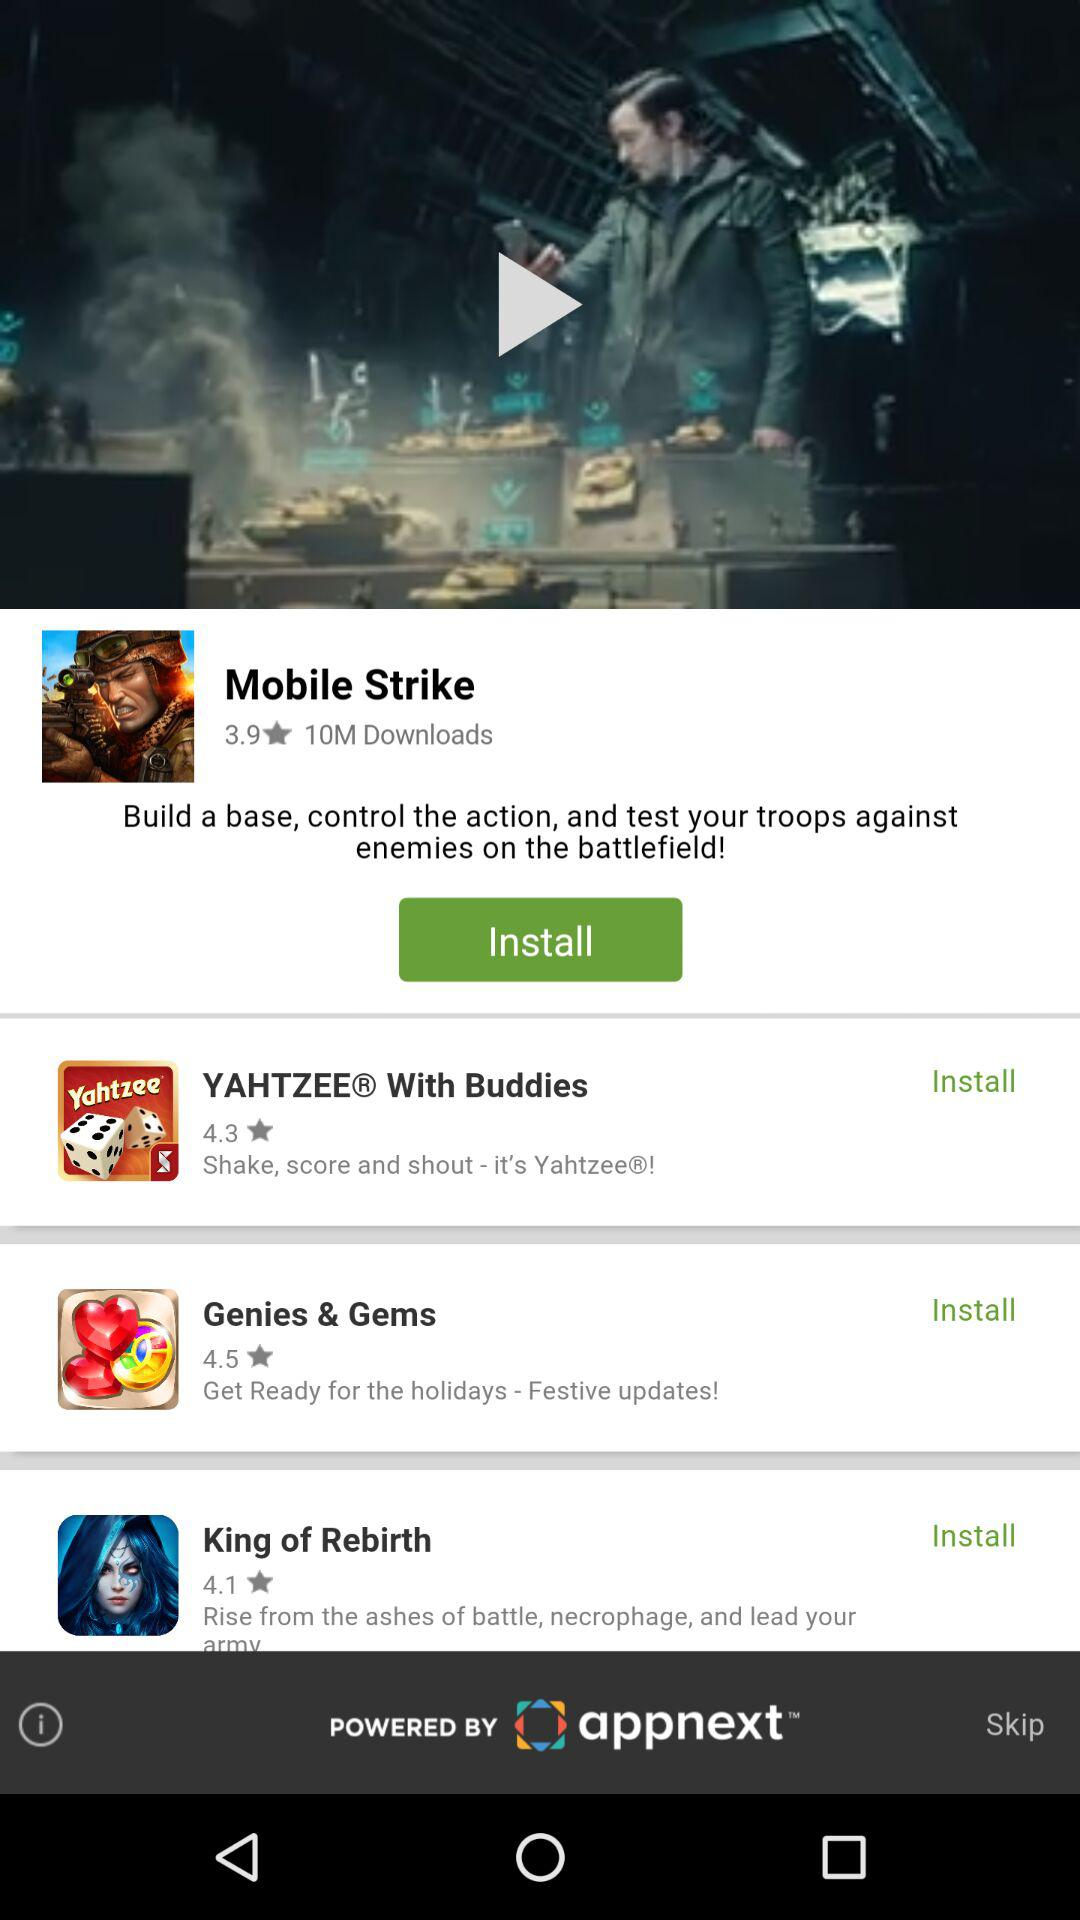What is the rating of "King of Rebirth"? The rating of "King of Rebirth" is 4.1 stars. 